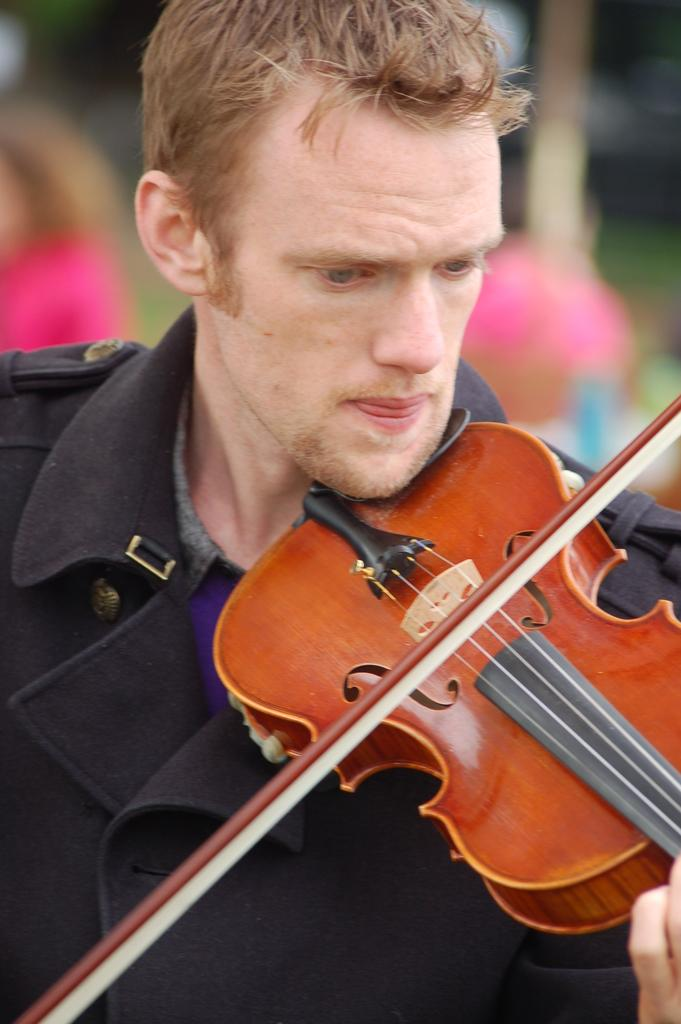What is the person in the image doing? The person is playing a violin. What type of clothing is the person wearing? The person is wearing a jacket. Can you describe the background of the image? The background of the image is blurry. What type of agreement did the person's aunt make with them before they started playing the violin in the image? There is no mention of an aunt or any agreement in the image, so it cannot be determined from the image. 